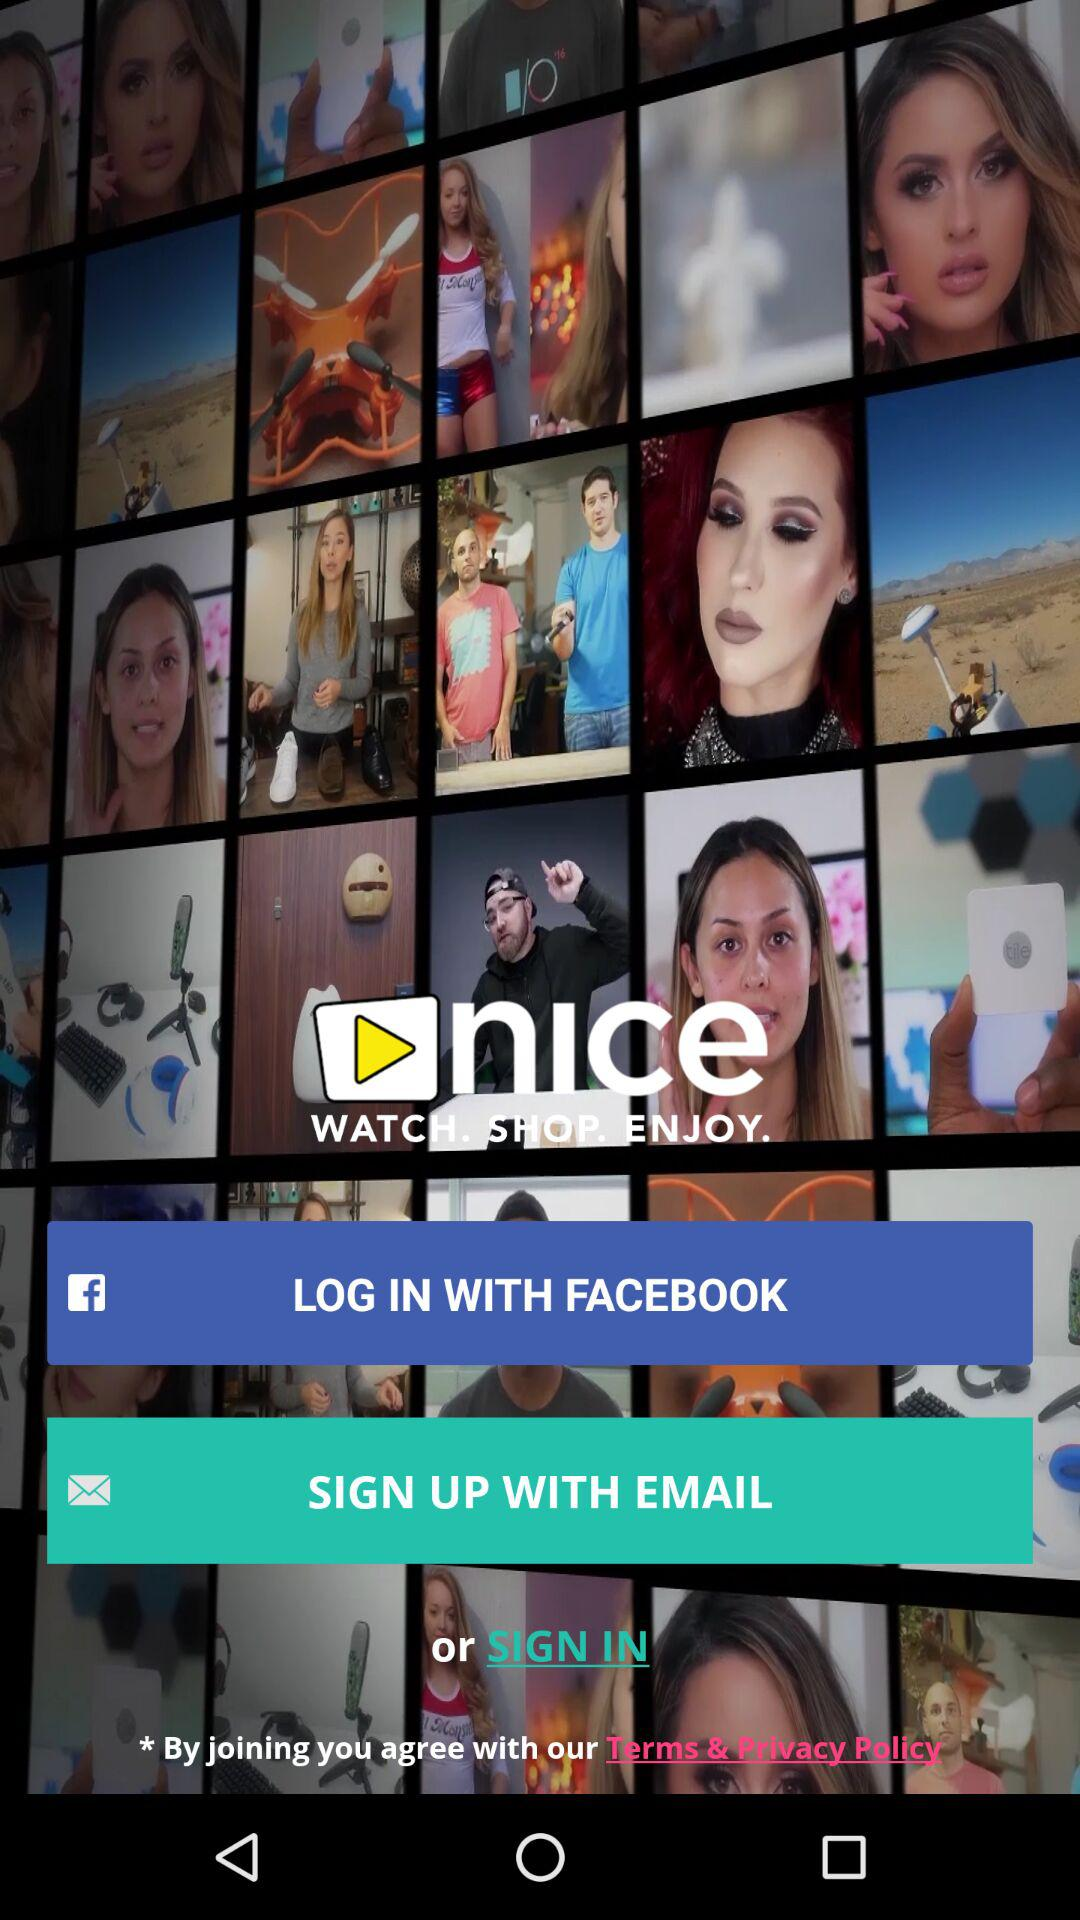What accounts can I use to sign up? You can sign up with "FACEBOOK" and "EMAIL". 